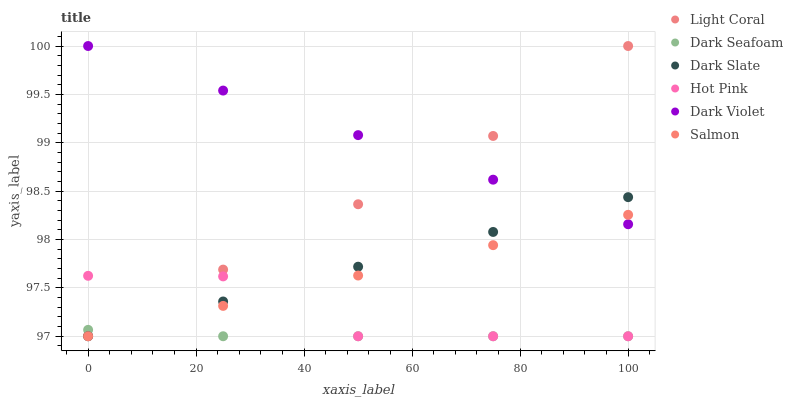Does Dark Seafoam have the minimum area under the curve?
Answer yes or no. Yes. Does Dark Violet have the maximum area under the curve?
Answer yes or no. Yes. Does Salmon have the minimum area under the curve?
Answer yes or no. No. Does Salmon have the maximum area under the curve?
Answer yes or no. No. Is Dark Violet the smoothest?
Answer yes or no. Yes. Is Hot Pink the roughest?
Answer yes or no. Yes. Is Salmon the smoothest?
Answer yes or no. No. Is Salmon the roughest?
Answer yes or no. No. Does Hot Pink have the lowest value?
Answer yes or no. Yes. Does Dark Violet have the lowest value?
Answer yes or no. No. Does Light Coral have the highest value?
Answer yes or no. Yes. Does Salmon have the highest value?
Answer yes or no. No. Is Dark Seafoam less than Dark Violet?
Answer yes or no. Yes. Is Dark Violet greater than Dark Seafoam?
Answer yes or no. Yes. Does Hot Pink intersect Salmon?
Answer yes or no. Yes. Is Hot Pink less than Salmon?
Answer yes or no. No. Is Hot Pink greater than Salmon?
Answer yes or no. No. Does Dark Seafoam intersect Dark Violet?
Answer yes or no. No. 